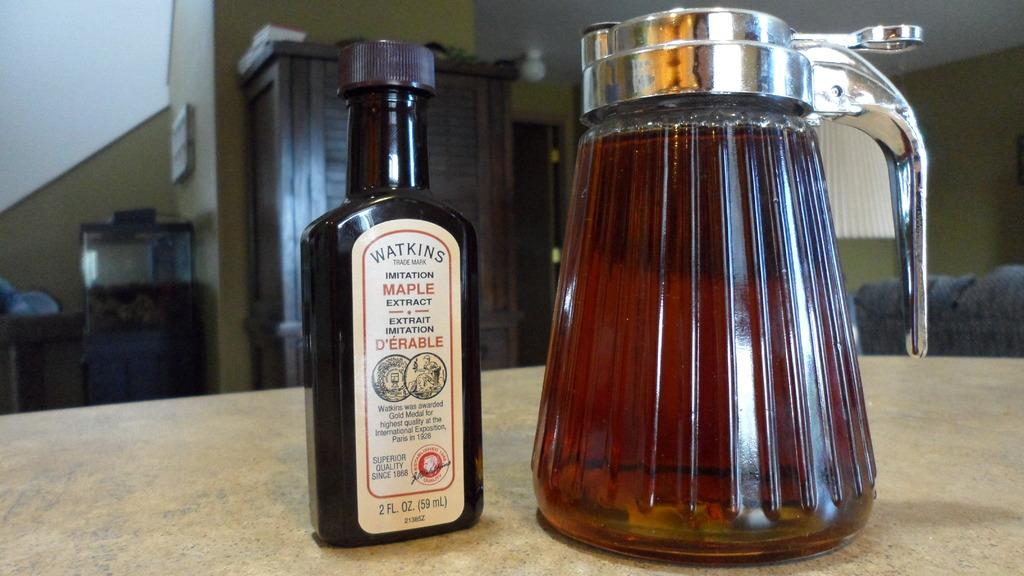<image>
Describe the image concisely. A bottle of imitation maple extract sits beside a carafe. 